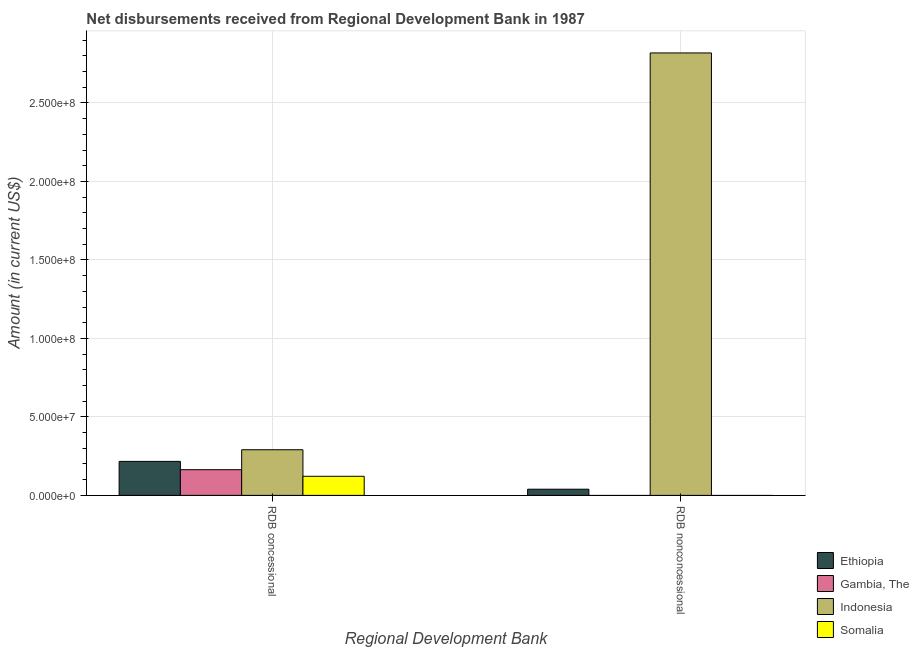How many groups of bars are there?
Provide a short and direct response. 2. Are the number of bars per tick equal to the number of legend labels?
Provide a succinct answer. No. Are the number of bars on each tick of the X-axis equal?
Offer a terse response. No. How many bars are there on the 1st tick from the left?
Provide a succinct answer. 4. How many bars are there on the 1st tick from the right?
Your answer should be very brief. 2. What is the label of the 2nd group of bars from the left?
Your answer should be very brief. RDB nonconcessional. What is the net non concessional disbursements from rdb in Ethiopia?
Offer a terse response. 3.93e+06. Across all countries, what is the maximum net concessional disbursements from rdb?
Keep it short and to the point. 2.91e+07. In which country was the net concessional disbursements from rdb maximum?
Provide a short and direct response. Indonesia. What is the total net non concessional disbursements from rdb in the graph?
Offer a very short reply. 2.86e+08. What is the difference between the net concessional disbursements from rdb in Indonesia and that in Ethiopia?
Ensure brevity in your answer.  7.42e+06. What is the difference between the net non concessional disbursements from rdb in Indonesia and the net concessional disbursements from rdb in Somalia?
Make the answer very short. 2.70e+08. What is the average net non concessional disbursements from rdb per country?
Offer a terse response. 7.15e+07. What is the difference between the net concessional disbursements from rdb and net non concessional disbursements from rdb in Ethiopia?
Provide a succinct answer. 1.77e+07. In how many countries, is the net non concessional disbursements from rdb greater than 250000000 US$?
Provide a short and direct response. 1. What is the ratio of the net non concessional disbursements from rdb in Indonesia to that in Ethiopia?
Offer a terse response. 71.69. Is the net concessional disbursements from rdb in Ethiopia less than that in Gambia, The?
Provide a short and direct response. No. In how many countries, is the net concessional disbursements from rdb greater than the average net concessional disbursements from rdb taken over all countries?
Provide a short and direct response. 2. Does the graph contain grids?
Ensure brevity in your answer.  Yes. What is the title of the graph?
Your answer should be compact. Net disbursements received from Regional Development Bank in 1987. Does "Russian Federation" appear as one of the legend labels in the graph?
Make the answer very short. No. What is the label or title of the X-axis?
Your answer should be compact. Regional Development Bank. What is the label or title of the Y-axis?
Your answer should be very brief. Amount (in current US$). What is the Amount (in current US$) in Ethiopia in RDB concessional?
Provide a succinct answer. 2.17e+07. What is the Amount (in current US$) of Gambia, The in RDB concessional?
Your answer should be very brief. 1.64e+07. What is the Amount (in current US$) of Indonesia in RDB concessional?
Make the answer very short. 2.91e+07. What is the Amount (in current US$) in Somalia in RDB concessional?
Your answer should be very brief. 1.22e+07. What is the Amount (in current US$) in Ethiopia in RDB nonconcessional?
Offer a terse response. 3.93e+06. What is the Amount (in current US$) in Gambia, The in RDB nonconcessional?
Your answer should be compact. 0. What is the Amount (in current US$) of Indonesia in RDB nonconcessional?
Provide a short and direct response. 2.82e+08. What is the Amount (in current US$) in Somalia in RDB nonconcessional?
Provide a short and direct response. 0. Across all Regional Development Bank, what is the maximum Amount (in current US$) in Ethiopia?
Make the answer very short. 2.17e+07. Across all Regional Development Bank, what is the maximum Amount (in current US$) of Gambia, The?
Make the answer very short. 1.64e+07. Across all Regional Development Bank, what is the maximum Amount (in current US$) in Indonesia?
Offer a very short reply. 2.82e+08. Across all Regional Development Bank, what is the maximum Amount (in current US$) in Somalia?
Your answer should be very brief. 1.22e+07. Across all Regional Development Bank, what is the minimum Amount (in current US$) of Ethiopia?
Keep it short and to the point. 3.93e+06. Across all Regional Development Bank, what is the minimum Amount (in current US$) in Gambia, The?
Offer a very short reply. 0. Across all Regional Development Bank, what is the minimum Amount (in current US$) of Indonesia?
Offer a very short reply. 2.91e+07. Across all Regional Development Bank, what is the minimum Amount (in current US$) in Somalia?
Ensure brevity in your answer.  0. What is the total Amount (in current US$) in Ethiopia in the graph?
Provide a short and direct response. 2.56e+07. What is the total Amount (in current US$) in Gambia, The in the graph?
Your answer should be compact. 1.64e+07. What is the total Amount (in current US$) in Indonesia in the graph?
Your response must be concise. 3.11e+08. What is the total Amount (in current US$) in Somalia in the graph?
Provide a succinct answer. 1.22e+07. What is the difference between the Amount (in current US$) in Ethiopia in RDB concessional and that in RDB nonconcessional?
Ensure brevity in your answer.  1.77e+07. What is the difference between the Amount (in current US$) of Indonesia in RDB concessional and that in RDB nonconcessional?
Give a very brief answer. -2.53e+08. What is the difference between the Amount (in current US$) in Ethiopia in RDB concessional and the Amount (in current US$) in Indonesia in RDB nonconcessional?
Make the answer very short. -2.60e+08. What is the difference between the Amount (in current US$) in Gambia, The in RDB concessional and the Amount (in current US$) in Indonesia in RDB nonconcessional?
Offer a terse response. -2.65e+08. What is the average Amount (in current US$) in Ethiopia per Regional Development Bank?
Make the answer very short. 1.28e+07. What is the average Amount (in current US$) in Gambia, The per Regional Development Bank?
Provide a short and direct response. 8.19e+06. What is the average Amount (in current US$) of Indonesia per Regional Development Bank?
Give a very brief answer. 1.55e+08. What is the average Amount (in current US$) of Somalia per Regional Development Bank?
Your answer should be compact. 6.08e+06. What is the difference between the Amount (in current US$) of Ethiopia and Amount (in current US$) of Gambia, The in RDB concessional?
Ensure brevity in your answer.  5.28e+06. What is the difference between the Amount (in current US$) of Ethiopia and Amount (in current US$) of Indonesia in RDB concessional?
Your response must be concise. -7.42e+06. What is the difference between the Amount (in current US$) in Ethiopia and Amount (in current US$) in Somalia in RDB concessional?
Your response must be concise. 9.49e+06. What is the difference between the Amount (in current US$) in Gambia, The and Amount (in current US$) in Indonesia in RDB concessional?
Offer a terse response. -1.27e+07. What is the difference between the Amount (in current US$) of Gambia, The and Amount (in current US$) of Somalia in RDB concessional?
Ensure brevity in your answer.  4.22e+06. What is the difference between the Amount (in current US$) of Indonesia and Amount (in current US$) of Somalia in RDB concessional?
Your answer should be very brief. 1.69e+07. What is the difference between the Amount (in current US$) in Ethiopia and Amount (in current US$) in Indonesia in RDB nonconcessional?
Give a very brief answer. -2.78e+08. What is the ratio of the Amount (in current US$) of Ethiopia in RDB concessional to that in RDB nonconcessional?
Your response must be concise. 5.51. What is the ratio of the Amount (in current US$) of Indonesia in RDB concessional to that in RDB nonconcessional?
Make the answer very short. 0.1. What is the difference between the highest and the second highest Amount (in current US$) of Ethiopia?
Provide a short and direct response. 1.77e+07. What is the difference between the highest and the second highest Amount (in current US$) in Indonesia?
Your answer should be very brief. 2.53e+08. What is the difference between the highest and the lowest Amount (in current US$) in Ethiopia?
Ensure brevity in your answer.  1.77e+07. What is the difference between the highest and the lowest Amount (in current US$) in Gambia, The?
Offer a very short reply. 1.64e+07. What is the difference between the highest and the lowest Amount (in current US$) of Indonesia?
Provide a short and direct response. 2.53e+08. What is the difference between the highest and the lowest Amount (in current US$) of Somalia?
Offer a very short reply. 1.22e+07. 